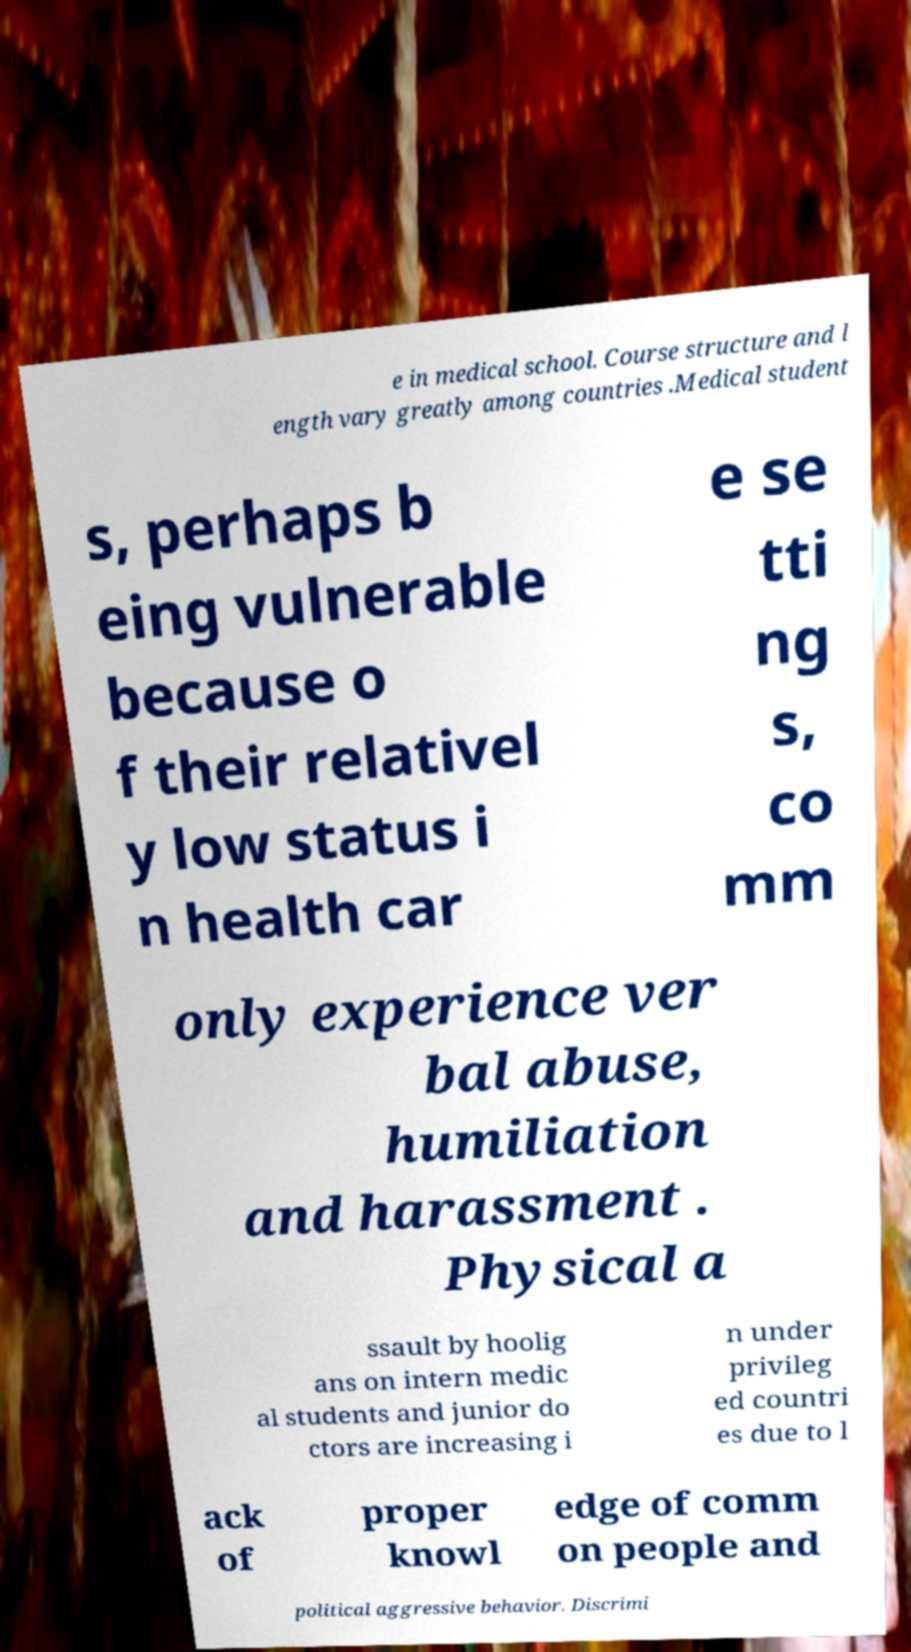Can you accurately transcribe the text from the provided image for me? e in medical school. Course structure and l ength vary greatly among countries .Medical student s, perhaps b eing vulnerable because o f their relativel y low status i n health car e se tti ng s, co mm only experience ver bal abuse, humiliation and harassment . Physical a ssault by hoolig ans on intern medic al students and junior do ctors are increasing i n under privileg ed countri es due to l ack of proper knowl edge of comm on people and political aggressive behavior. Discrimi 